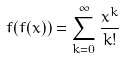<formula> <loc_0><loc_0><loc_500><loc_500>f ( f ( x ) ) = \sum _ { k = 0 } ^ { \infty } \frac { x ^ { k } } { k ! }</formula> 